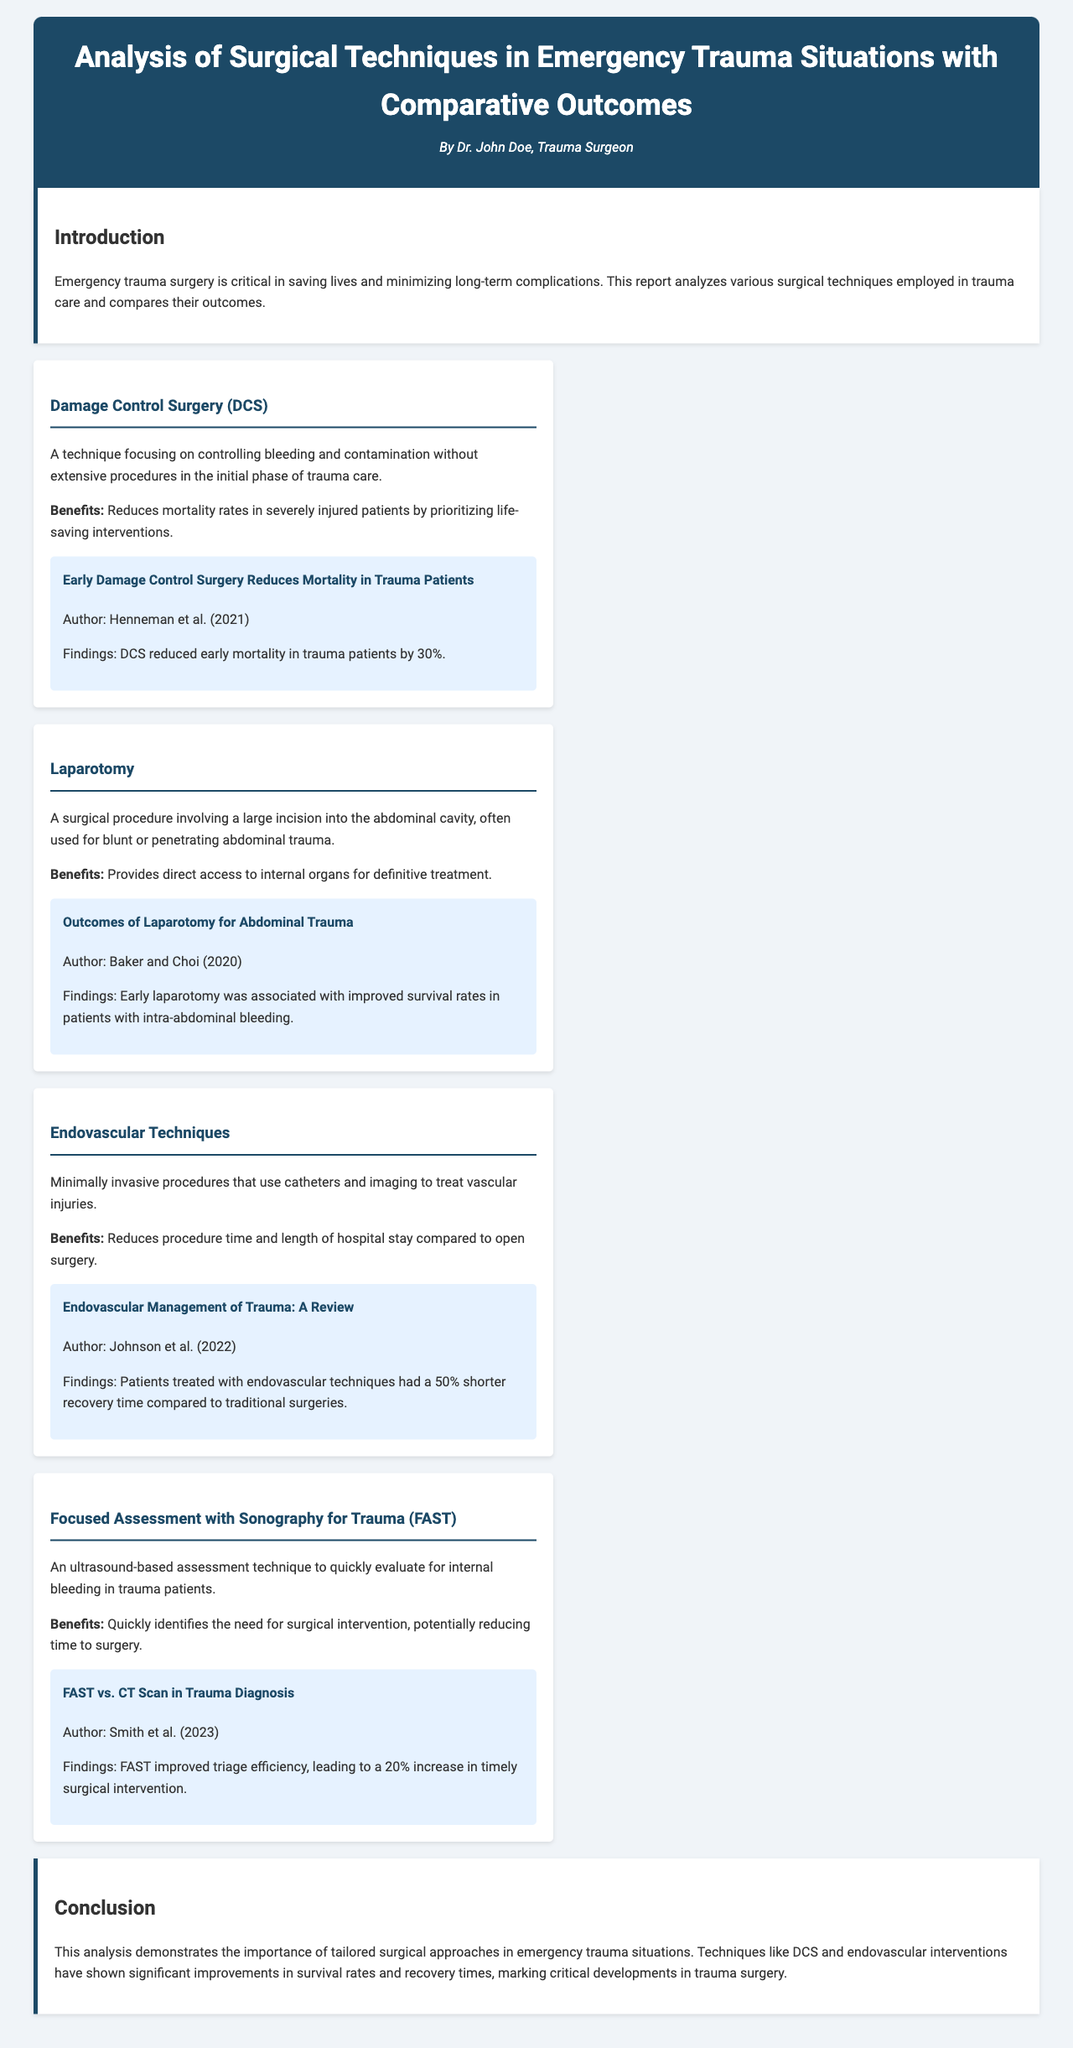What is the main focus of the report? The main focus of the report is on the analysis of various surgical techniques employed in trauma care and their outcomes.
Answer: surgical techniques employed in trauma care and their outcomes Who is the author of the report? The report was authored by Dr. John Doe.
Answer: Dr. John Doe What technique reduces early mortality in trauma patients by 30%? The technique that reduces early mortality in trauma patients by 30% is Damage Control Surgery (DCS).
Answer: Damage Control Surgery (DCS) What is the key benefit of endovascular techniques? The key benefit of endovascular techniques is reducing procedure time and length of hospital stay compared to open surgery.
Answer: reducing procedure time and length of hospital stay Which technique demonstrated a 20% increase in timely surgical intervention? The technique that demonstrated a 20% increase in timely surgical intervention is Focused Assessment with Sonography for Trauma (FAST).
Answer: Focused Assessment with Sonography for Trauma (FAST) How many studies are cited in the document? The document cites four studies in total.
Answer: four studies What year was the study on laparotomy published? The study on laparotomy was published in the year 2020.
Answer: 2020 Which technique involves a large incision into the abdominal cavity? The technique that involves a large incision into the abdominal cavity is Laparotomy.
Answer: Laparotomy 